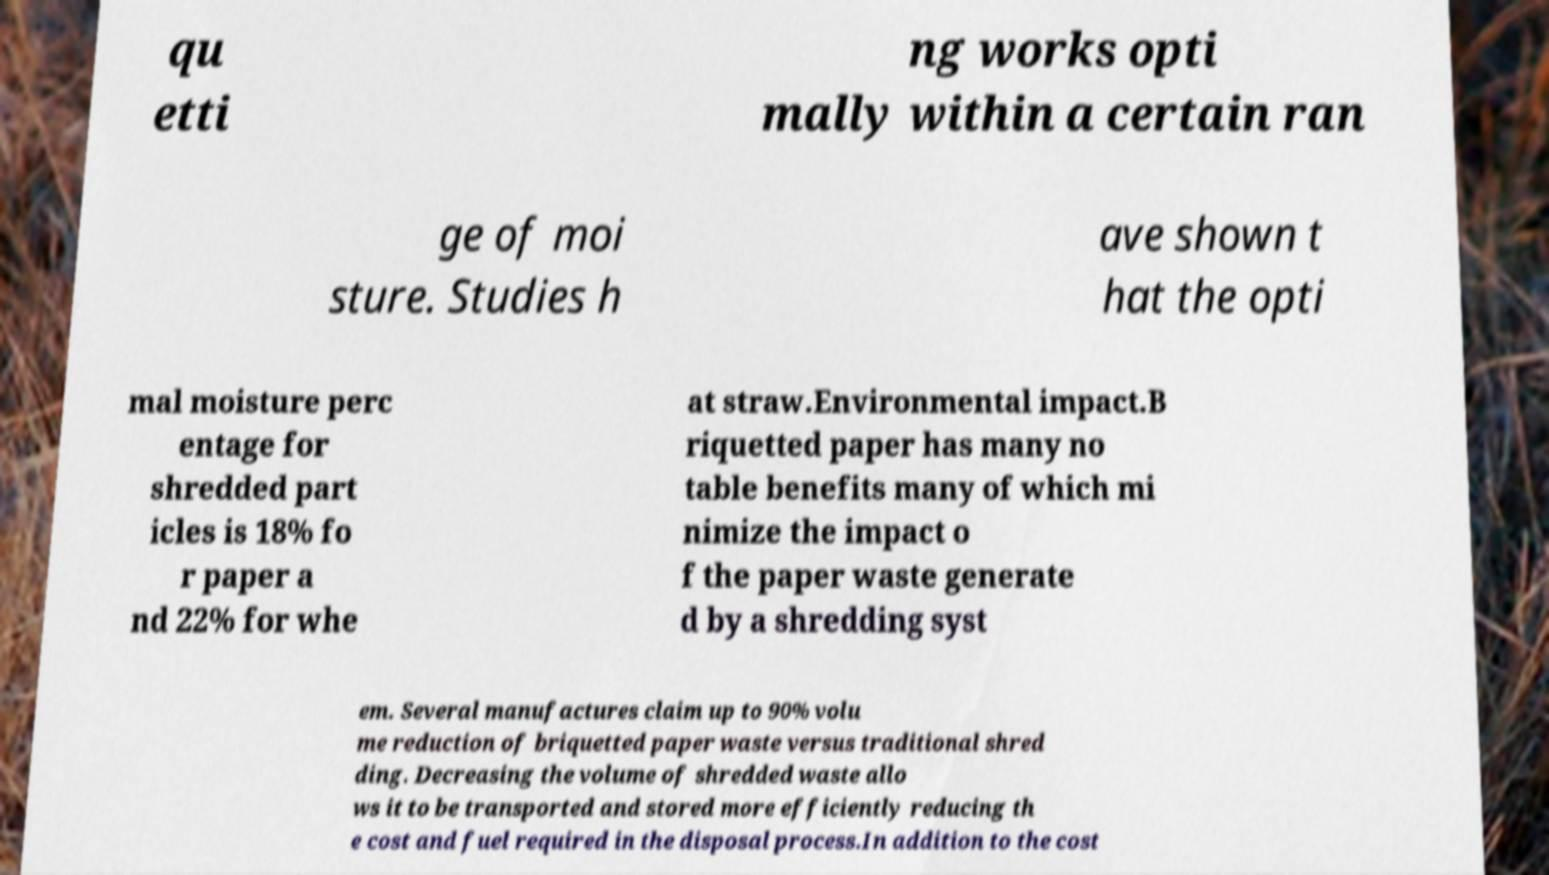Can you read and provide the text displayed in the image?This photo seems to have some interesting text. Can you extract and type it out for me? qu etti ng works opti mally within a certain ran ge of moi sture. Studies h ave shown t hat the opti mal moisture perc entage for shredded part icles is 18% fo r paper a nd 22% for whe at straw.Environmental impact.B riquetted paper has many no table benefits many of which mi nimize the impact o f the paper waste generate d by a shredding syst em. Several manufactures claim up to 90% volu me reduction of briquetted paper waste versus traditional shred ding. Decreasing the volume of shredded waste allo ws it to be transported and stored more efficiently reducing th e cost and fuel required in the disposal process.In addition to the cost 